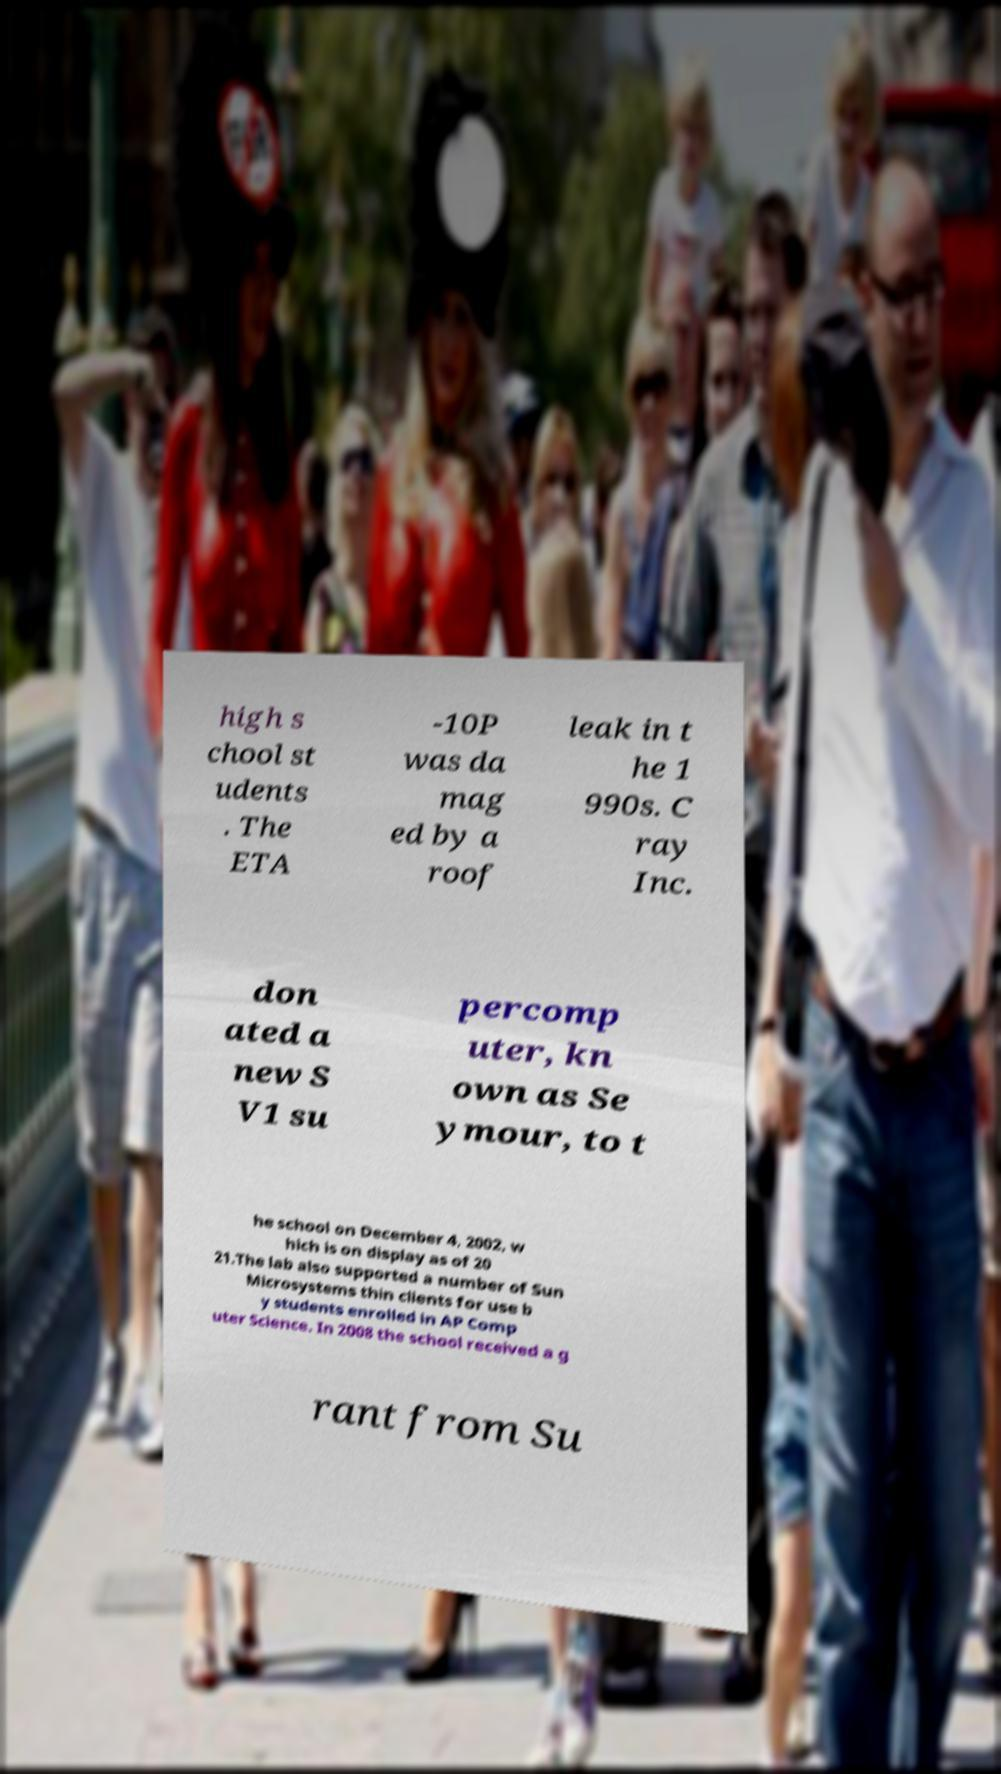Please read and relay the text visible in this image. What does it say? high s chool st udents . The ETA -10P was da mag ed by a roof leak in t he 1 990s. C ray Inc. don ated a new S V1 su percomp uter, kn own as Se ymour, to t he school on December 4, 2002, w hich is on display as of 20 21.The lab also supported a number of Sun Microsystems thin clients for use b y students enrolled in AP Comp uter Science. In 2008 the school received a g rant from Su 